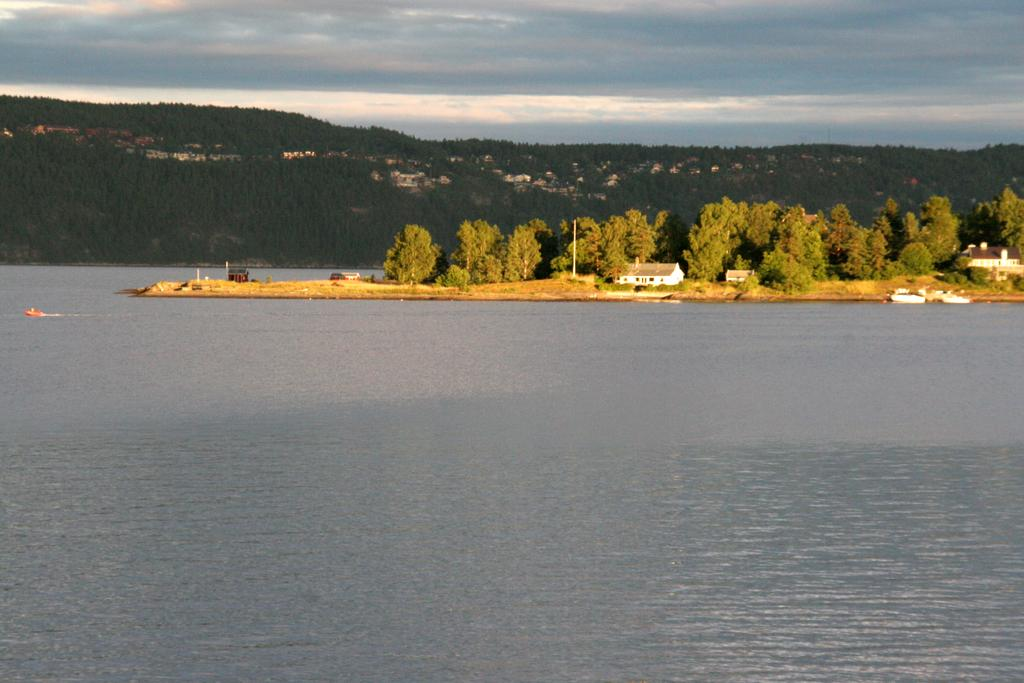What is the primary element in the image? There is water in the image. What is floating on the water? Boats are floating on the water. What type of structures can be seen in the image? There are houses visible in the image. What other natural elements are present in the image? Trees and hills are visible in the image. How would you describe the sky in the background? The sky is cloudy in the background. Where is the feather located in the image? There is no feather present in the image. What type of church can be seen in the image? There is no church present in the image. 